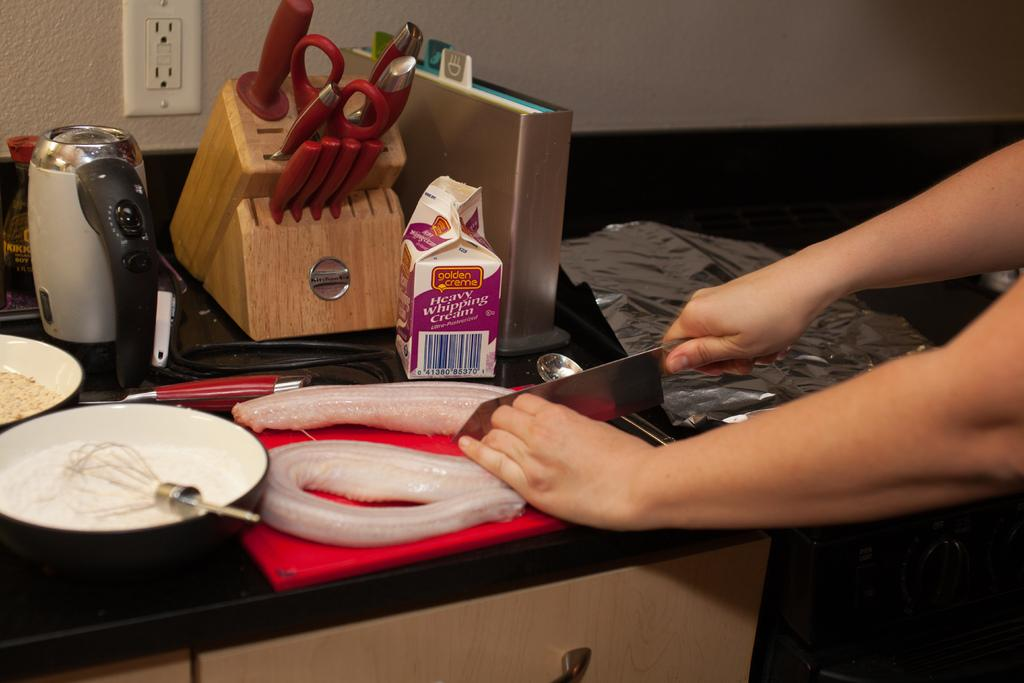What is the person in the image doing? The person is cutting fish in the image. What tool is the person using to cut the fish? The person is using a knife. What other objects can be seen in the image? There is a stirrer, containers, a scissor, and a cream pack on a counter in the image. Is the person in the image trying to escape from quicksand? There is no quicksand present in the image; the person is cutting fish. What happens when the cream pack bursts in the image? There is no cream pack bursting in the image; it is on a counter and appears to be intact. 